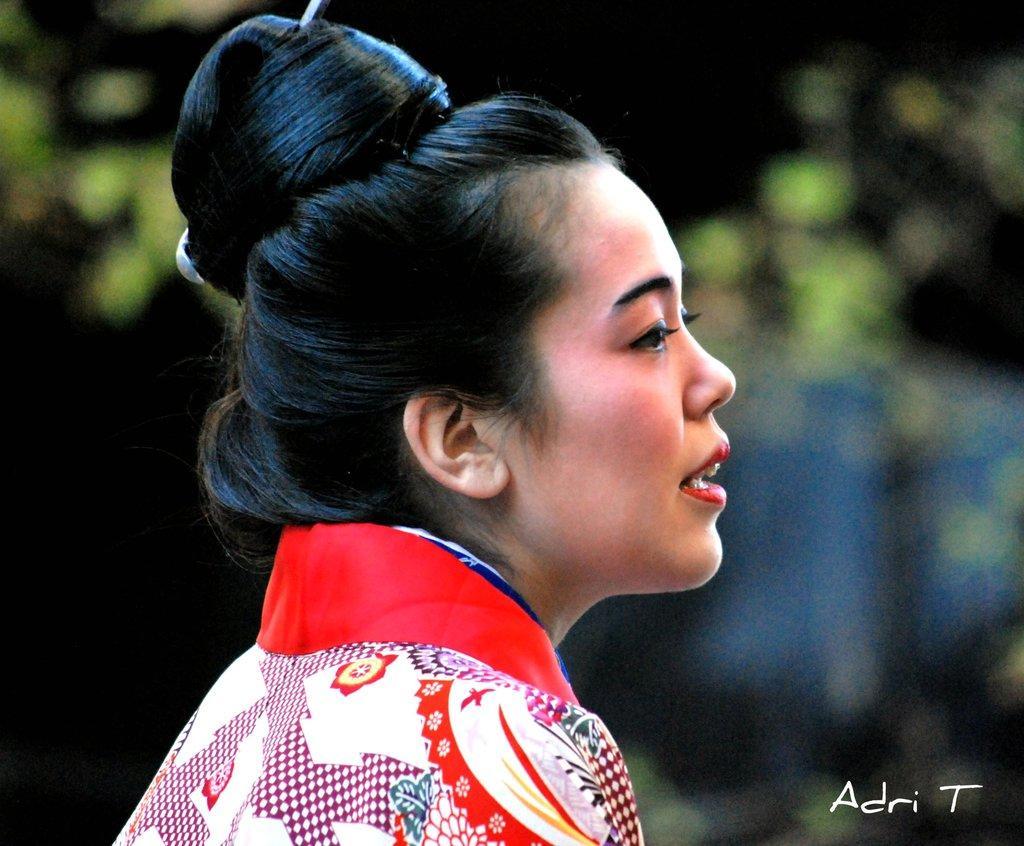Can you describe this image briefly? In this image there is a woman, there is text towards the bottom of the image, the background of the image is blurred. 